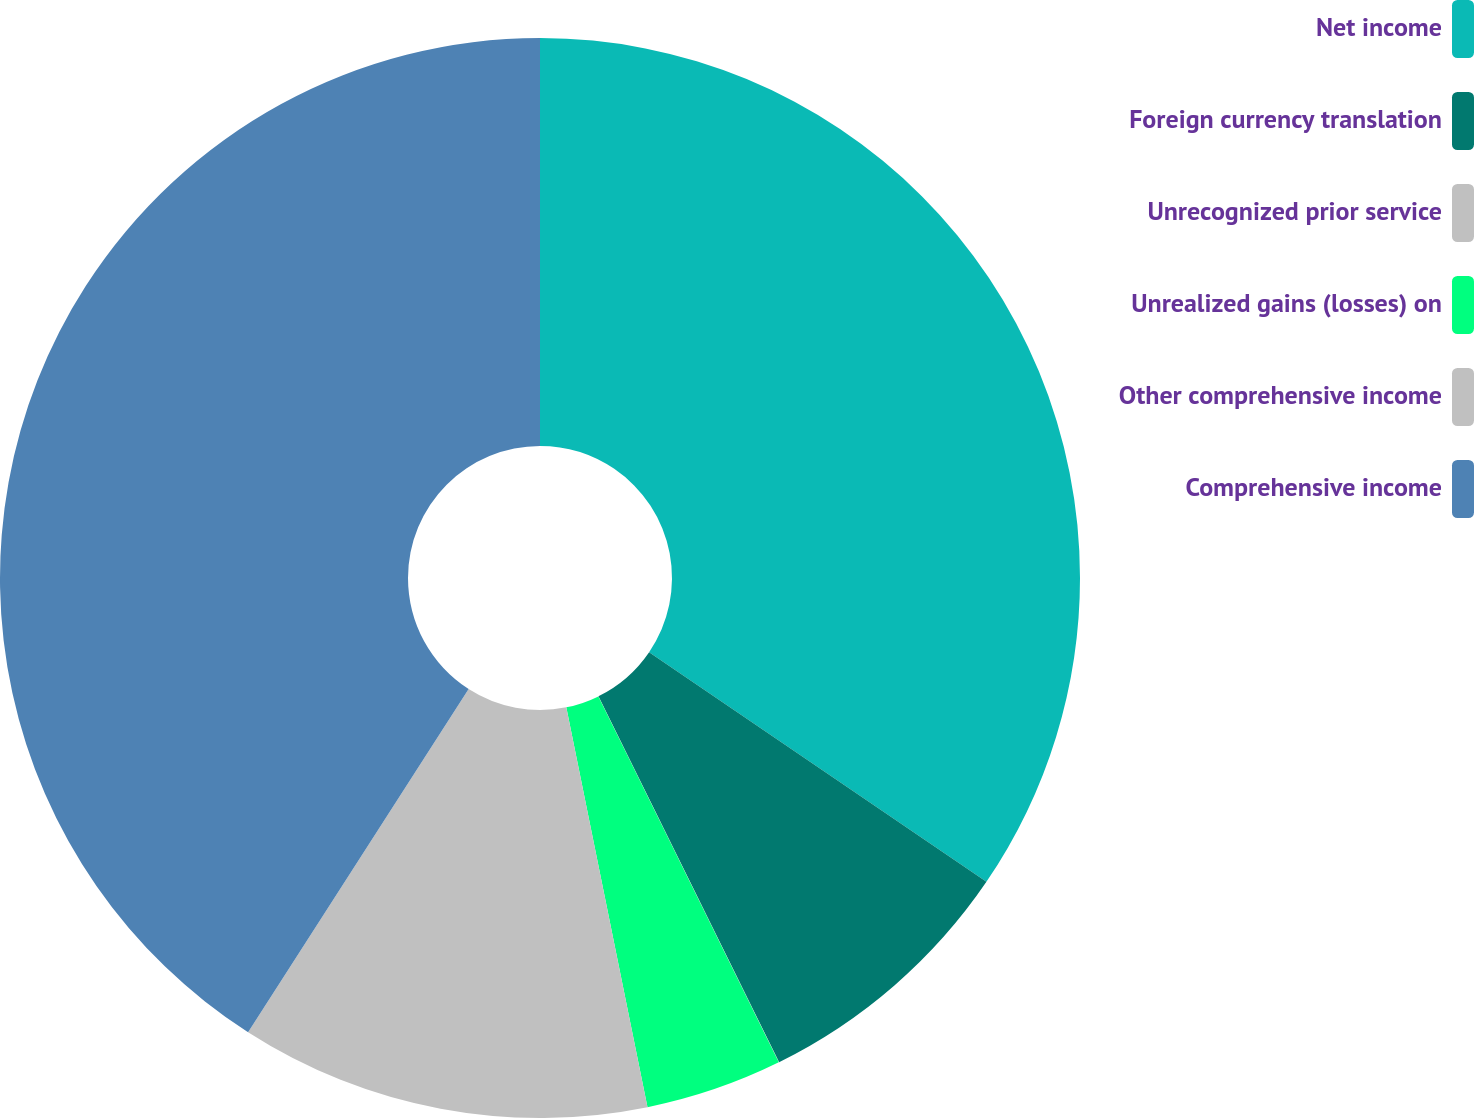Convert chart. <chart><loc_0><loc_0><loc_500><loc_500><pie_chart><fcel>Net income<fcel>Foreign currency translation<fcel>Unrecognized prior service<fcel>Unrealized gains (losses) on<fcel>Other comprehensive income<fcel>Comprehensive income<nl><fcel>34.51%<fcel>8.19%<fcel>0.01%<fcel>4.1%<fcel>12.28%<fcel>40.91%<nl></chart> 